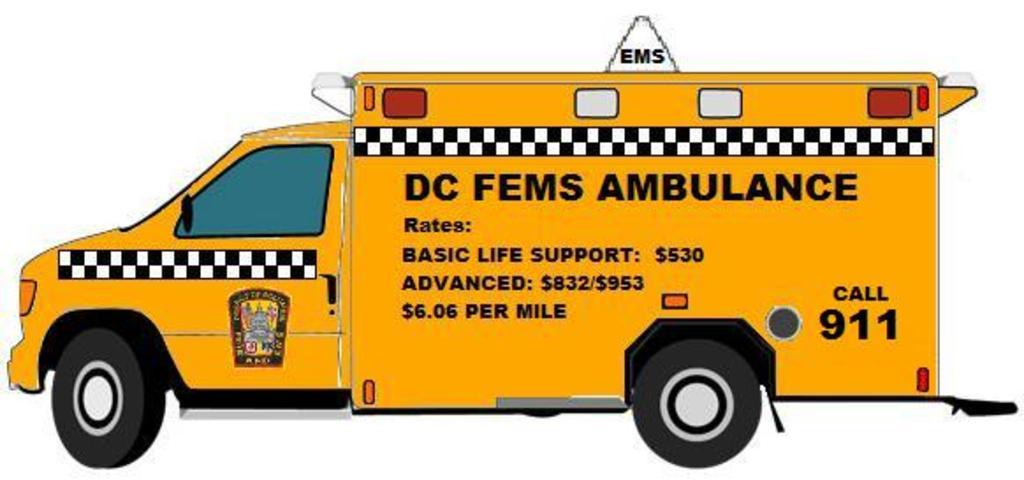What is depicted on the poster in the image? The poster features a yellow ambulance. Are there any other details on the ambulance besides its color? Yes, there is text and numerical numbers on the ambulance. How many lizards are climbing on the rake in the image? There are no lizards or rakes present in the image; it features a poster with a yellow ambulance. 